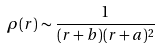Convert formula to latex. <formula><loc_0><loc_0><loc_500><loc_500>\rho ( r ) \sim \frac { 1 } { ( r + b ) ( r + a ) ^ { 2 } }</formula> 